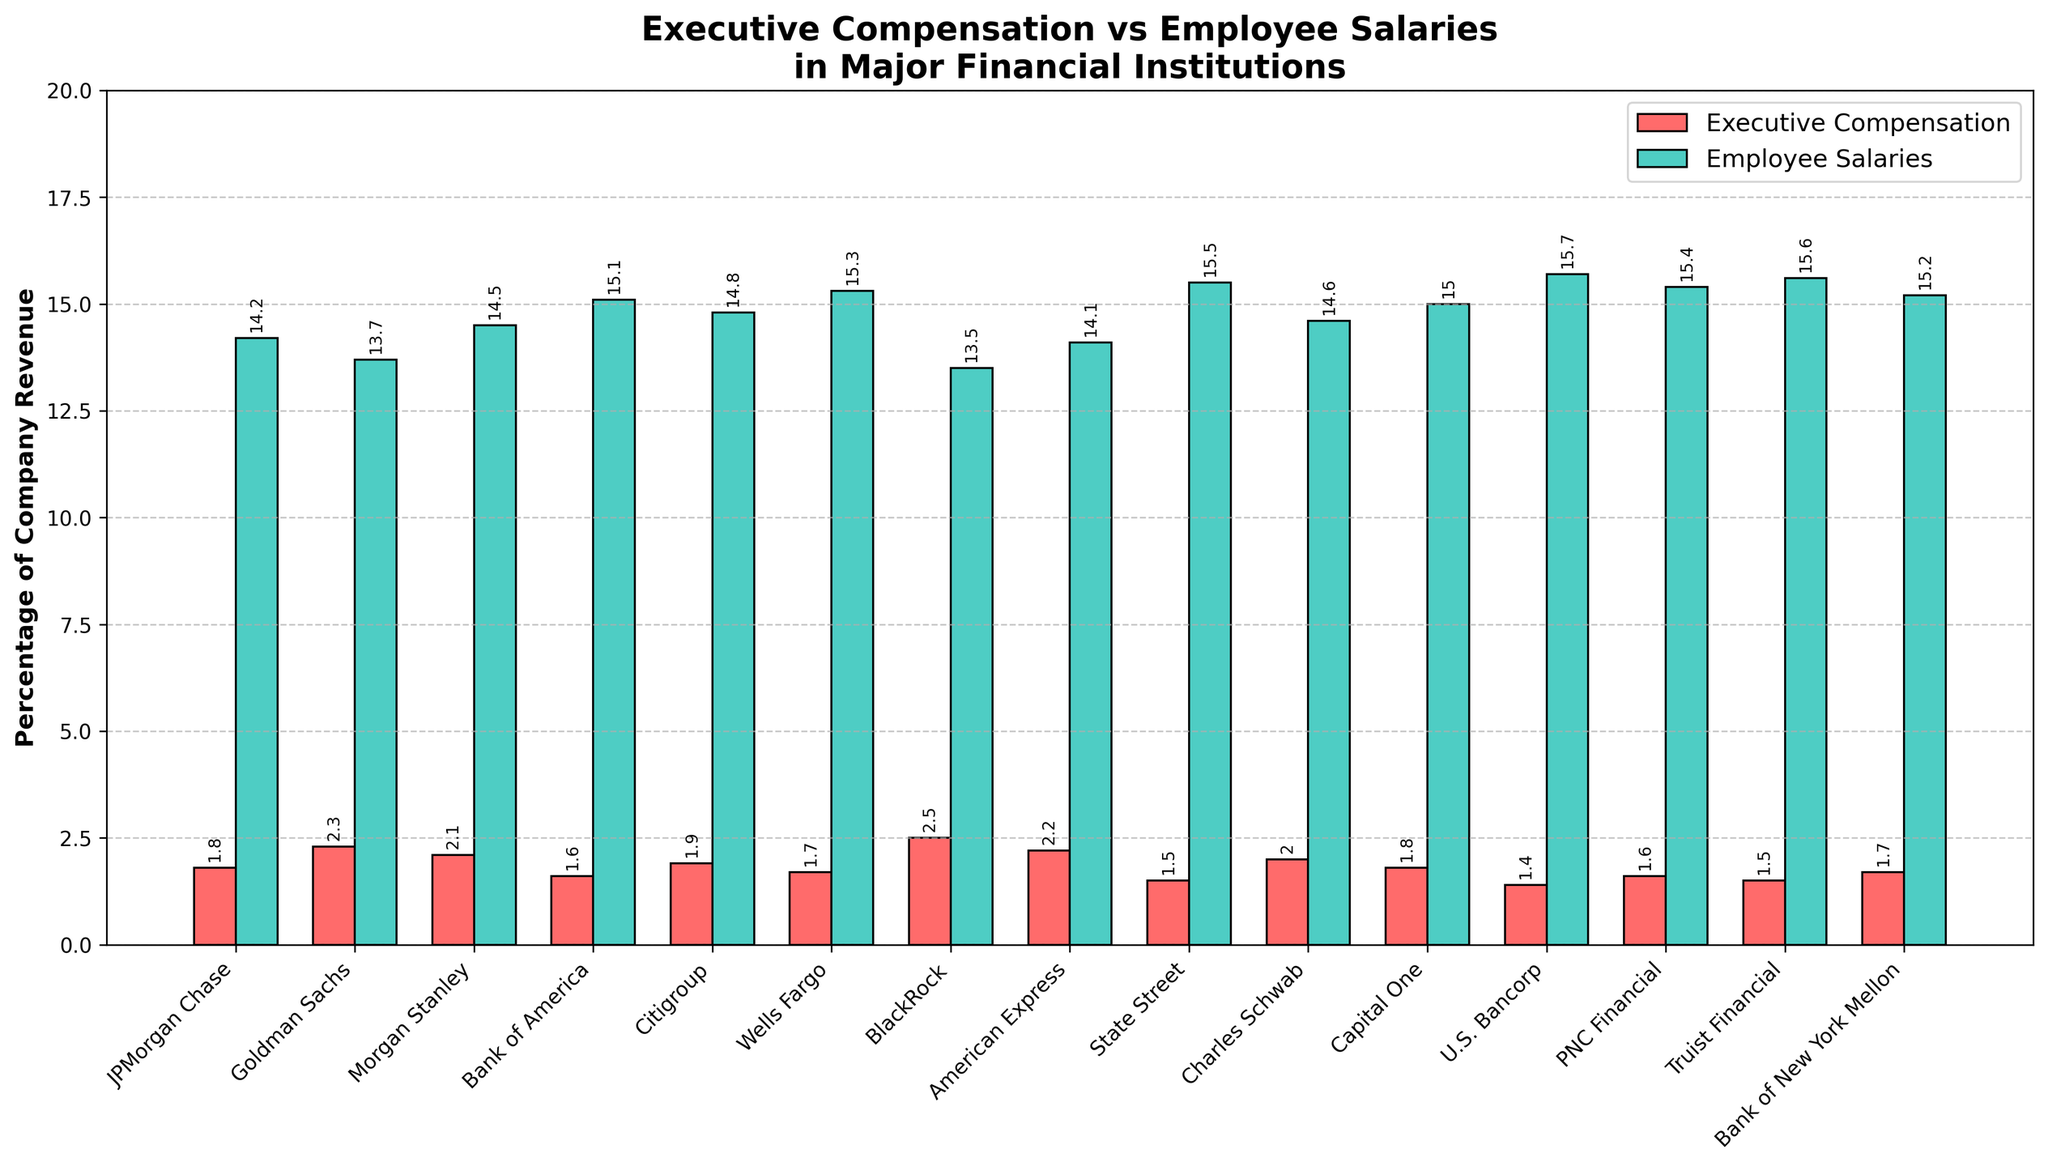Which institution allocates the highest percentage of revenue to executive compensation? The highest bar in the executive compensation category is colored red. By examining the bars, BlackRock allocates the highest percentage at 2.5%.
Answer: BlackRock Which institution allocates the lowest percentage of revenue to employee salaries? The shortest bar in the employee salaries category is colored green. By examining the bars, BlackRock allocates the lowest percentage at 13.5%.
Answer: BlackRock What's the difference between the percentage of company revenue allocated to executive compensation and employee salaries at JPMorgan Chase? For JPMorgan Chase, executive compensation is 1.8% and employee salaries are 14.2%. The difference is calculated as 14.2 - 1.8 = 12.4%.
Answer: 12.4% Is there any institution that allocates exactly 2% of revenue to executive compensation? By looking at the red bars representing executive compensation, Charles Schwab allocates exactly 2% of revenue to executive compensation.
Answer: Charles Schwab Which institution allocates a higher percentage of revenue to employee salaries, Morgan Stanley or Citigroup? By comparing the green bars representing employee salaries for Morgan Stanley (14.5%) and Citigroup (14.8%), Citigroup allocates a higher percentage.
Answer: Citigroup Which institution has the smallest gap between the percentage of revenue allocated to executive compensation and employee salaries? Calculate the difference for each institution, the smallest gap is found for Truist Financial with 15.6 - 1.5 = 14.1.
Answer: Truist Financial What's the sum of the percentages allocated to executive compensation by Goldman Sachs, Morgan Stanley, and BlackRock? Goldman Sachs allocates 2.3%, Morgan Stanley 2.1%, and BlackRock 2.5%. The sum is 2.3 + 2.1 + 2.5 = 6.9%.
Answer: 6.9% Which institution has a higher overall percentage allocation (sum of executive compensation and employee salaries), PNC Financial or Bank of New York Mellon? For PNC Financial, the sum is 1.6 + 15.4 = 17.0%. For Bank of New York Mellon, the sum is 1.7 + 15.2 = 16.9%. PNC Financial has a higher overall percentage allocation.
Answer: PNC Financial How many institutions allocate more than 15% of their revenue to employee salaries? By counting the green bars above 15%, there are six institutions (Wells Fargo, U.S. Bancorp, PNC Financial, Truist Financial, Bank of New York Mellon, and Capital One).
Answer: 6 